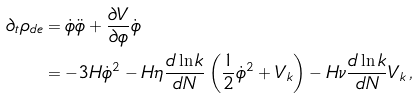<formula> <loc_0><loc_0><loc_500><loc_500>\partial _ { t } \rho _ { d e } & = \dot { \phi } \ddot { \phi } + \frac { \partial V } { \partial \phi } \dot { \phi } \\ & = - 3 H \dot { \phi } ^ { 2 } - H \eta \frac { d \ln k } { d N } \left ( \frac { 1 } { 2 } \dot { \phi } ^ { 2 } + V _ { k } \right ) - H \nu \frac { d \ln k } { d N } V _ { k } \, ,</formula> 